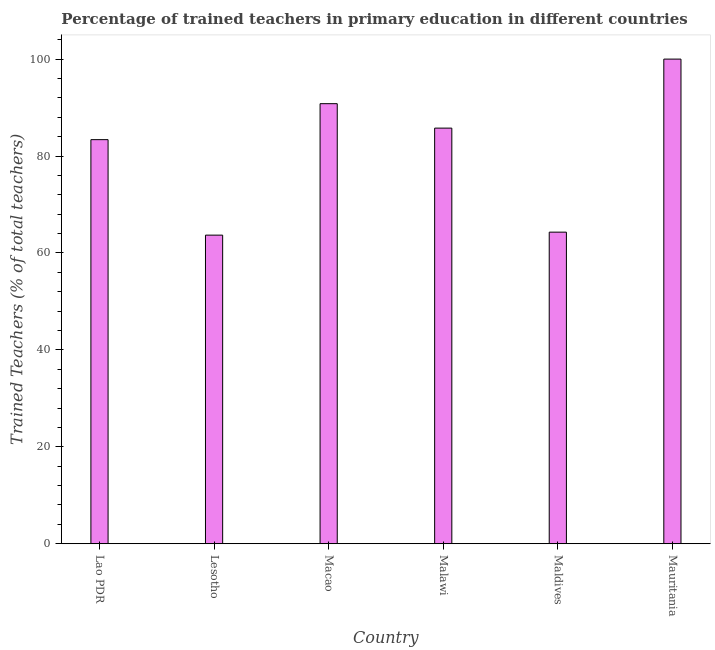Does the graph contain grids?
Your answer should be compact. No. What is the title of the graph?
Give a very brief answer. Percentage of trained teachers in primary education in different countries. What is the label or title of the X-axis?
Your answer should be compact. Country. What is the label or title of the Y-axis?
Provide a short and direct response. Trained Teachers (% of total teachers). What is the percentage of trained teachers in Malawi?
Offer a terse response. 85.76. Across all countries, what is the maximum percentage of trained teachers?
Provide a short and direct response. 100. Across all countries, what is the minimum percentage of trained teachers?
Your response must be concise. 63.68. In which country was the percentage of trained teachers maximum?
Make the answer very short. Mauritania. In which country was the percentage of trained teachers minimum?
Provide a short and direct response. Lesotho. What is the sum of the percentage of trained teachers?
Offer a very short reply. 487.92. What is the difference between the percentage of trained teachers in Macao and Mauritania?
Keep it short and to the point. -9.2. What is the average percentage of trained teachers per country?
Provide a short and direct response. 81.32. What is the median percentage of trained teachers?
Offer a terse response. 84.57. What is the ratio of the percentage of trained teachers in Lao PDR to that in Lesotho?
Provide a succinct answer. 1.31. What is the difference between the highest and the second highest percentage of trained teachers?
Your response must be concise. 9.2. What is the difference between the highest and the lowest percentage of trained teachers?
Provide a short and direct response. 36.32. How many bars are there?
Provide a succinct answer. 6. Are all the bars in the graph horizontal?
Your answer should be very brief. No. What is the difference between two consecutive major ticks on the Y-axis?
Keep it short and to the point. 20. Are the values on the major ticks of Y-axis written in scientific E-notation?
Offer a terse response. No. What is the Trained Teachers (% of total teachers) in Lao PDR?
Your response must be concise. 83.38. What is the Trained Teachers (% of total teachers) in Lesotho?
Make the answer very short. 63.68. What is the Trained Teachers (% of total teachers) of Macao?
Ensure brevity in your answer.  90.8. What is the Trained Teachers (% of total teachers) of Malawi?
Your answer should be very brief. 85.76. What is the Trained Teachers (% of total teachers) in Maldives?
Your answer should be compact. 64.3. What is the Trained Teachers (% of total teachers) in Mauritania?
Offer a terse response. 100. What is the difference between the Trained Teachers (% of total teachers) in Lao PDR and Lesotho?
Your response must be concise. 19.7. What is the difference between the Trained Teachers (% of total teachers) in Lao PDR and Macao?
Keep it short and to the point. -7.42. What is the difference between the Trained Teachers (% of total teachers) in Lao PDR and Malawi?
Your answer should be very brief. -2.38. What is the difference between the Trained Teachers (% of total teachers) in Lao PDR and Maldives?
Your answer should be compact. 19.09. What is the difference between the Trained Teachers (% of total teachers) in Lao PDR and Mauritania?
Your response must be concise. -16.62. What is the difference between the Trained Teachers (% of total teachers) in Lesotho and Macao?
Offer a terse response. -27.12. What is the difference between the Trained Teachers (% of total teachers) in Lesotho and Malawi?
Offer a terse response. -22.08. What is the difference between the Trained Teachers (% of total teachers) in Lesotho and Maldives?
Give a very brief answer. -0.62. What is the difference between the Trained Teachers (% of total teachers) in Lesotho and Mauritania?
Ensure brevity in your answer.  -36.32. What is the difference between the Trained Teachers (% of total teachers) in Macao and Malawi?
Your response must be concise. 5.04. What is the difference between the Trained Teachers (% of total teachers) in Macao and Maldives?
Provide a succinct answer. 26.51. What is the difference between the Trained Teachers (% of total teachers) in Macao and Mauritania?
Provide a short and direct response. -9.2. What is the difference between the Trained Teachers (% of total teachers) in Malawi and Maldives?
Offer a terse response. 21.46. What is the difference between the Trained Teachers (% of total teachers) in Malawi and Mauritania?
Your answer should be compact. -14.24. What is the difference between the Trained Teachers (% of total teachers) in Maldives and Mauritania?
Give a very brief answer. -35.7. What is the ratio of the Trained Teachers (% of total teachers) in Lao PDR to that in Lesotho?
Your answer should be very brief. 1.31. What is the ratio of the Trained Teachers (% of total teachers) in Lao PDR to that in Macao?
Provide a short and direct response. 0.92. What is the ratio of the Trained Teachers (% of total teachers) in Lao PDR to that in Malawi?
Your answer should be compact. 0.97. What is the ratio of the Trained Teachers (% of total teachers) in Lao PDR to that in Maldives?
Ensure brevity in your answer.  1.3. What is the ratio of the Trained Teachers (% of total teachers) in Lao PDR to that in Mauritania?
Give a very brief answer. 0.83. What is the ratio of the Trained Teachers (% of total teachers) in Lesotho to that in Macao?
Your response must be concise. 0.7. What is the ratio of the Trained Teachers (% of total teachers) in Lesotho to that in Malawi?
Make the answer very short. 0.74. What is the ratio of the Trained Teachers (% of total teachers) in Lesotho to that in Mauritania?
Provide a short and direct response. 0.64. What is the ratio of the Trained Teachers (% of total teachers) in Macao to that in Malawi?
Your answer should be compact. 1.06. What is the ratio of the Trained Teachers (% of total teachers) in Macao to that in Maldives?
Provide a succinct answer. 1.41. What is the ratio of the Trained Teachers (% of total teachers) in Macao to that in Mauritania?
Make the answer very short. 0.91. What is the ratio of the Trained Teachers (% of total teachers) in Malawi to that in Maldives?
Give a very brief answer. 1.33. What is the ratio of the Trained Teachers (% of total teachers) in Malawi to that in Mauritania?
Offer a very short reply. 0.86. What is the ratio of the Trained Teachers (% of total teachers) in Maldives to that in Mauritania?
Ensure brevity in your answer.  0.64. 